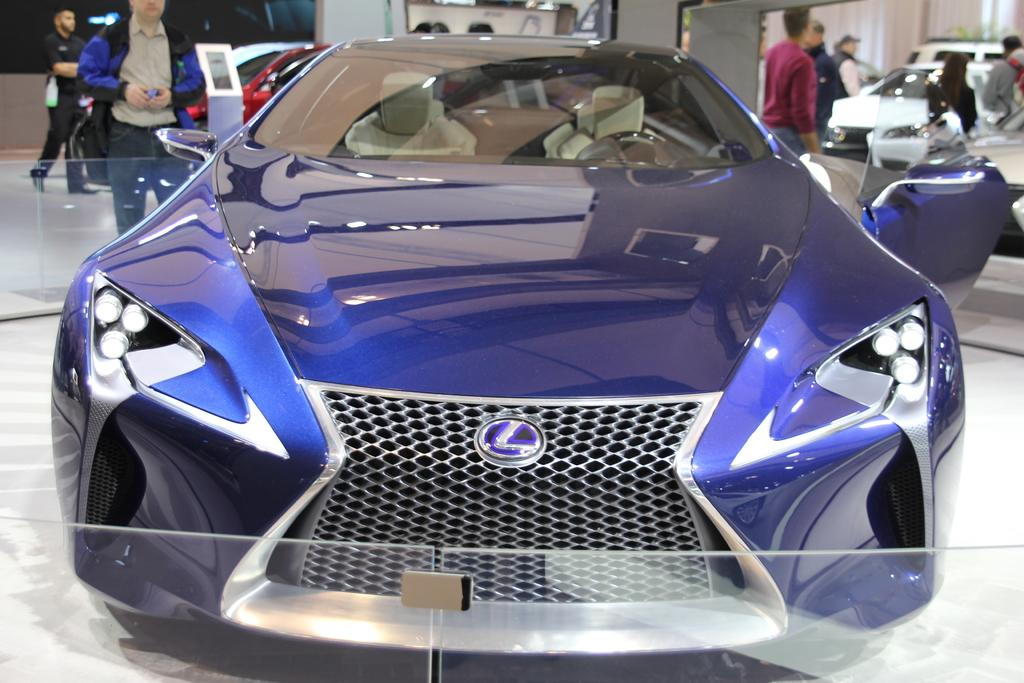Where was the image taken? The image was taken in a car showroom. What is the main subject in the foreground of the image? There is a car in the foreground of the image. Can you describe the people on the left side of the image? There are people on the left side of the image. What else can be seen in the middle of the image besides the car? There are cars and people in the middle of the image. What is the name of the sheep in the image? There are no sheep present in the image. How does the image end? The image does not have an ending, as it is a still photograph. 